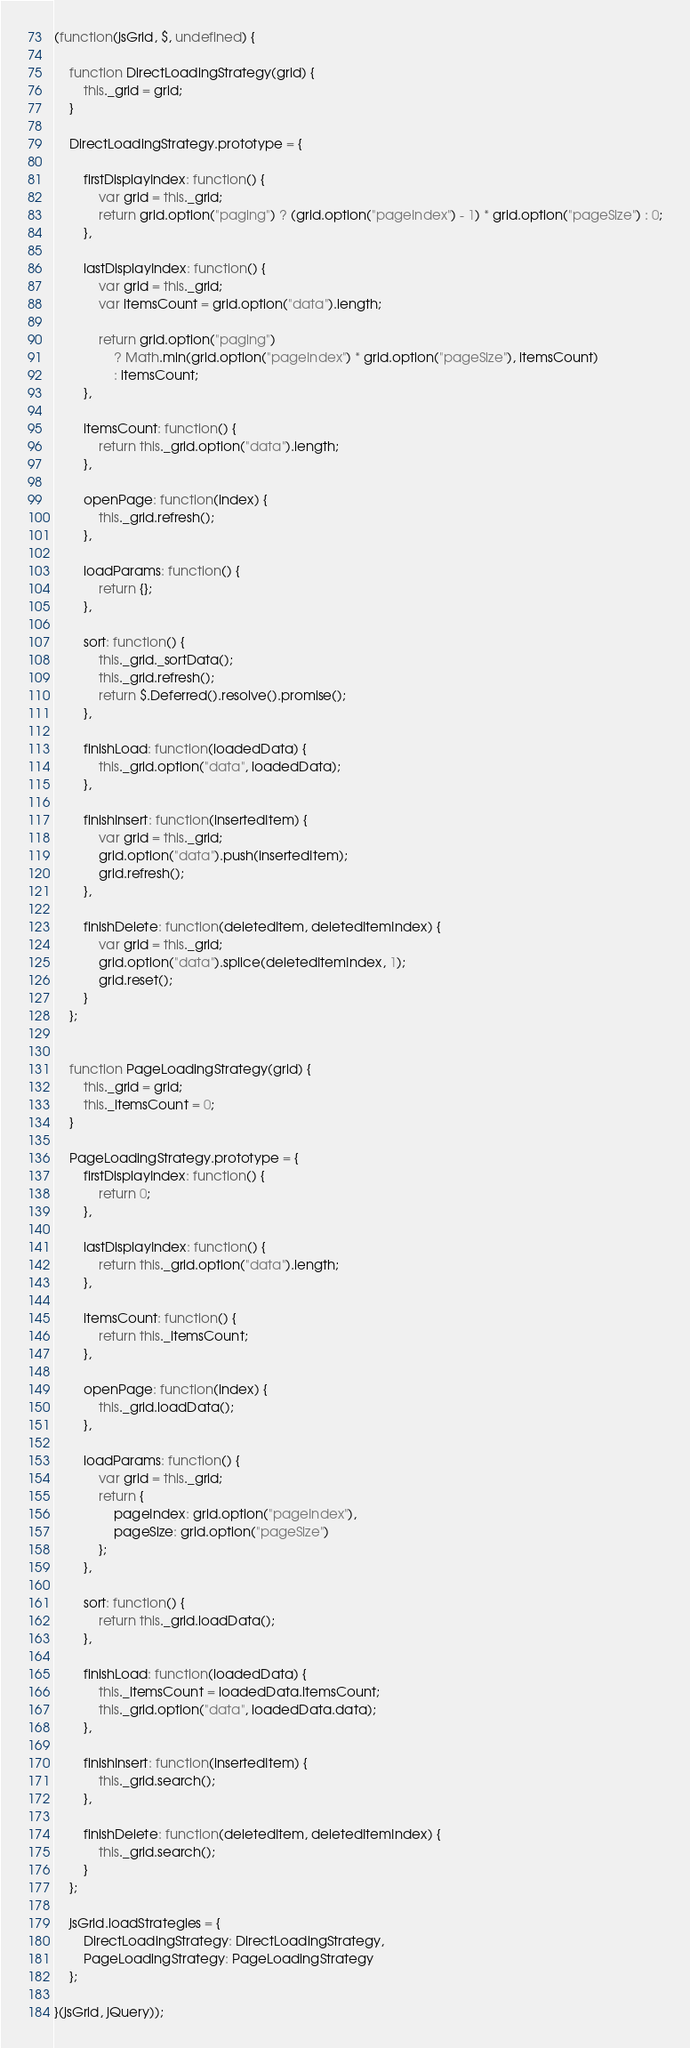Convert code to text. <code><loc_0><loc_0><loc_500><loc_500><_JavaScript_>(function(jsGrid, $, undefined) {

    function DirectLoadingStrategy(grid) {
        this._grid = grid;
    }

    DirectLoadingStrategy.prototype = {

        firstDisplayIndex: function() {
            var grid = this._grid;
            return grid.option("paging") ? (grid.option("pageIndex") - 1) * grid.option("pageSize") : 0;
        },

        lastDisplayIndex: function() {
            var grid = this._grid;
            var itemsCount = grid.option("data").length;

            return grid.option("paging")
                ? Math.min(grid.option("pageIndex") * grid.option("pageSize"), itemsCount)
                : itemsCount;
        },

        itemsCount: function() {
            return this._grid.option("data").length;
        },

        openPage: function(index) {
            this._grid.refresh();
        },

        loadParams: function() {
            return {};
        },

        sort: function() {
            this._grid._sortData();
            this._grid.refresh();
            return $.Deferred().resolve().promise();
        },

        finishLoad: function(loadedData) {
            this._grid.option("data", loadedData);
        },

        finishInsert: function(insertedItem) {
            var grid = this._grid;
            grid.option("data").push(insertedItem);
            grid.refresh();
        },

        finishDelete: function(deletedItem, deletedItemIndex) {
            var grid = this._grid;
            grid.option("data").splice(deletedItemIndex, 1);
            grid.reset();
        }
    };


    function PageLoadingStrategy(grid) {
        this._grid = grid;
        this._itemsCount = 0;
    }

    PageLoadingStrategy.prototype = {
        firstDisplayIndex: function() {
            return 0;
        },

        lastDisplayIndex: function() {
            return this._grid.option("data").length;
        },

        itemsCount: function() {
            return this._itemsCount;
        },

        openPage: function(index) {
            this._grid.loadData();
        },

        loadParams: function() {
            var grid = this._grid;
            return {
                pageIndex: grid.option("pageIndex"),
                pageSize: grid.option("pageSize")
            };
        },

        sort: function() {
            return this._grid.loadData();
        },

        finishLoad: function(loadedData) {
            this._itemsCount = loadedData.itemsCount;
            this._grid.option("data", loadedData.data);
        },

        finishInsert: function(insertedItem) {
            this._grid.search();
        },

        finishDelete: function(deletedItem, deletedItemIndex) {
            this._grid.search();
        }
    };

    jsGrid.loadStrategies = {
        DirectLoadingStrategy: DirectLoadingStrategy,
        PageLoadingStrategy: PageLoadingStrategy
    };

}(jsGrid, jQuery));
</code> 